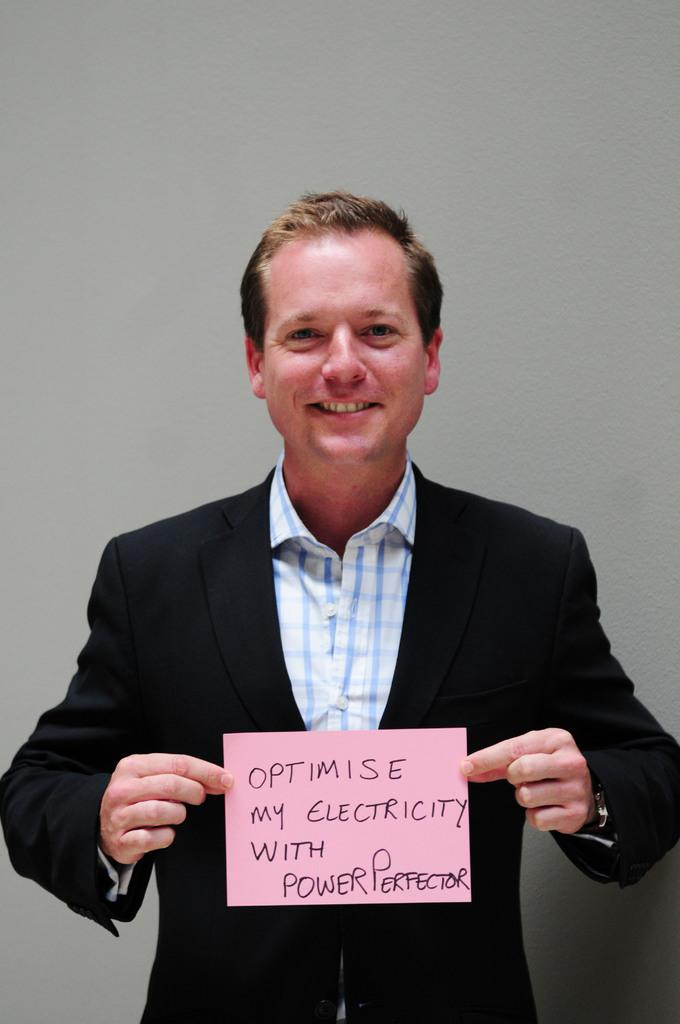What is the person in the image wearing? The person is wearing a black suit. What is the person doing in the image? The person is standing and holding a paper. What is written on the paper the person is holding? The paper has the text "Optimize My Electricity with Power Perfector" written on it. What type of yarn is the cow using to knit a sweater in the image? There is no cow or yarn present in the image. The person in the image is holding a paper with text about optimizing electricity. 